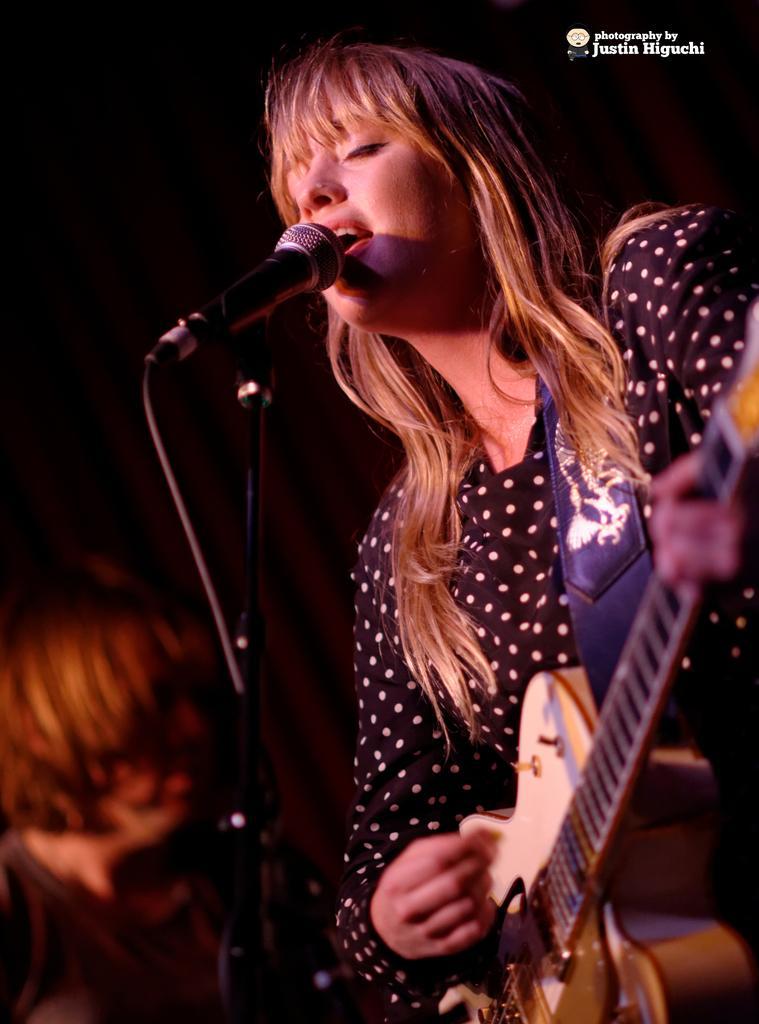In one or two sentences, can you explain what this image depicts? a person is standing,singing, playing guitar. she is wearing a black and white dotted dress. in front of her there is a microphone. behind her there is another person. at the back there is black background. 